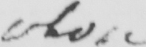Can you read and transcribe this handwriting? whose 